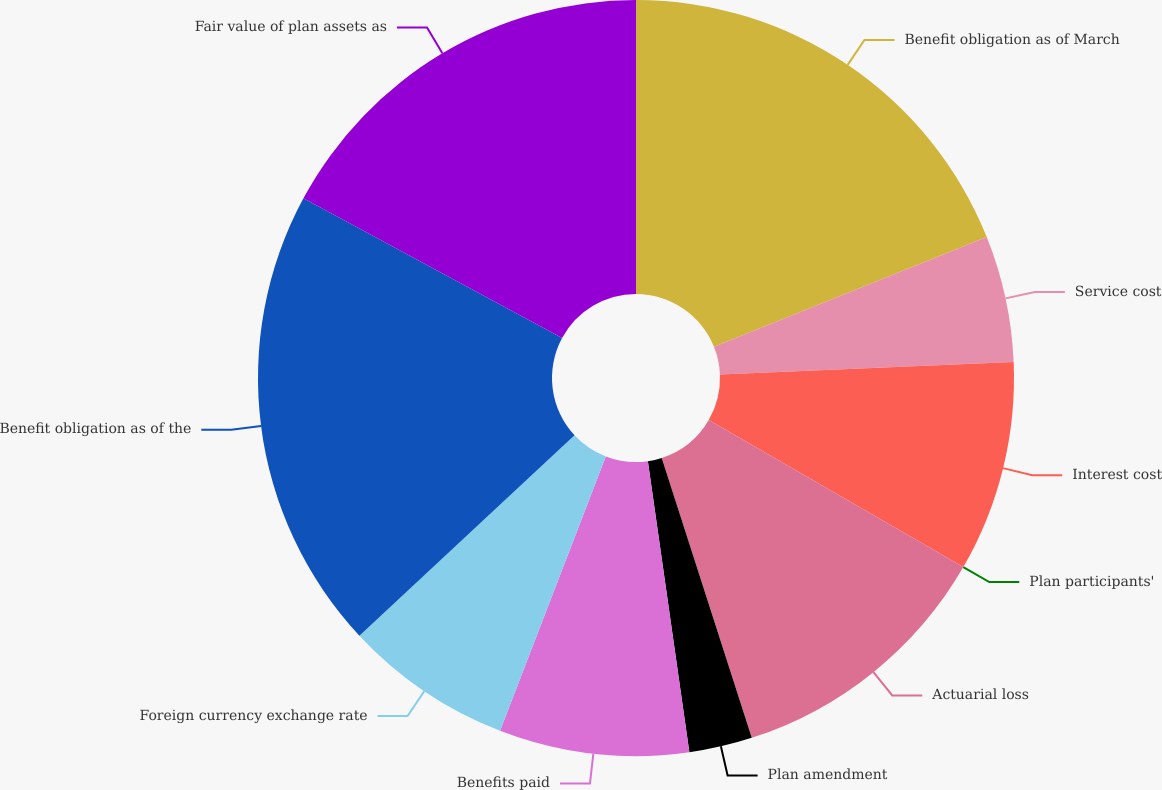Convert chart. <chart><loc_0><loc_0><loc_500><loc_500><pie_chart><fcel>Benefit obligation as of March<fcel>Service cost<fcel>Interest cost<fcel>Plan participants'<fcel>Actuarial loss<fcel>Plan amendment<fcel>Benefits paid<fcel>Foreign currency exchange rate<fcel>Benefit obligation as of the<fcel>Fair value of plan assets as<nl><fcel>18.92%<fcel>5.41%<fcel>9.01%<fcel>0.0%<fcel>11.71%<fcel>2.7%<fcel>8.11%<fcel>7.21%<fcel>19.82%<fcel>17.12%<nl></chart> 